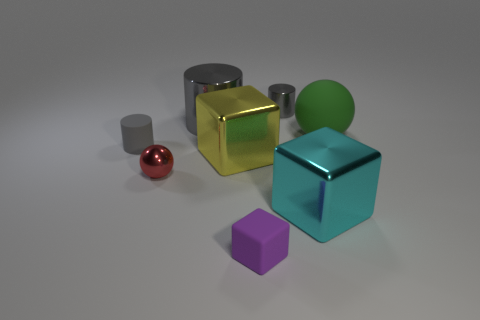There is a tiny matte thing behind the large cyan metal object; does it have the same shape as the gray metallic thing that is to the right of the purple matte block?
Your response must be concise. Yes. How many objects are small matte cylinders or tiny red cylinders?
Your answer should be compact. 1. Are there any other things that are made of the same material as the big yellow block?
Your answer should be very brief. Yes. Are any cyan matte cylinders visible?
Offer a very short reply. No. Is the material of the gray object to the right of the yellow thing the same as the tiny red ball?
Offer a very short reply. Yes. Is there another yellow shiny object that has the same shape as the large yellow metallic object?
Make the answer very short. No. Are there the same number of tiny gray cylinders that are in front of the big cyan metal block and purple blocks?
Give a very brief answer. No. The large thing to the right of the big block in front of the tiny shiny ball is made of what material?
Keep it short and to the point. Rubber. The big green thing is what shape?
Give a very brief answer. Sphere. Is the number of green objects right of the purple rubber block the same as the number of purple matte things behind the large matte sphere?
Your answer should be compact. No. 